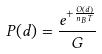<formula> <loc_0><loc_0><loc_500><loc_500>P ( d ) = \frac { e ^ { + \frac { O ( d ) } { n _ { B } T } } } { G }</formula> 